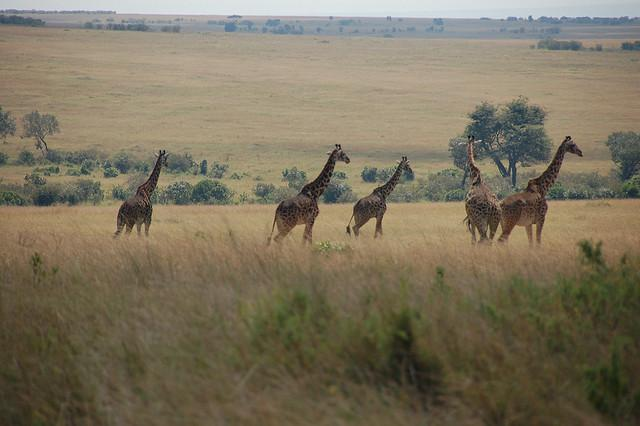Which giraffe is farthest from this small herd?

Choices:
A) far right
B) middle left
C) far left
D) middle right far left 